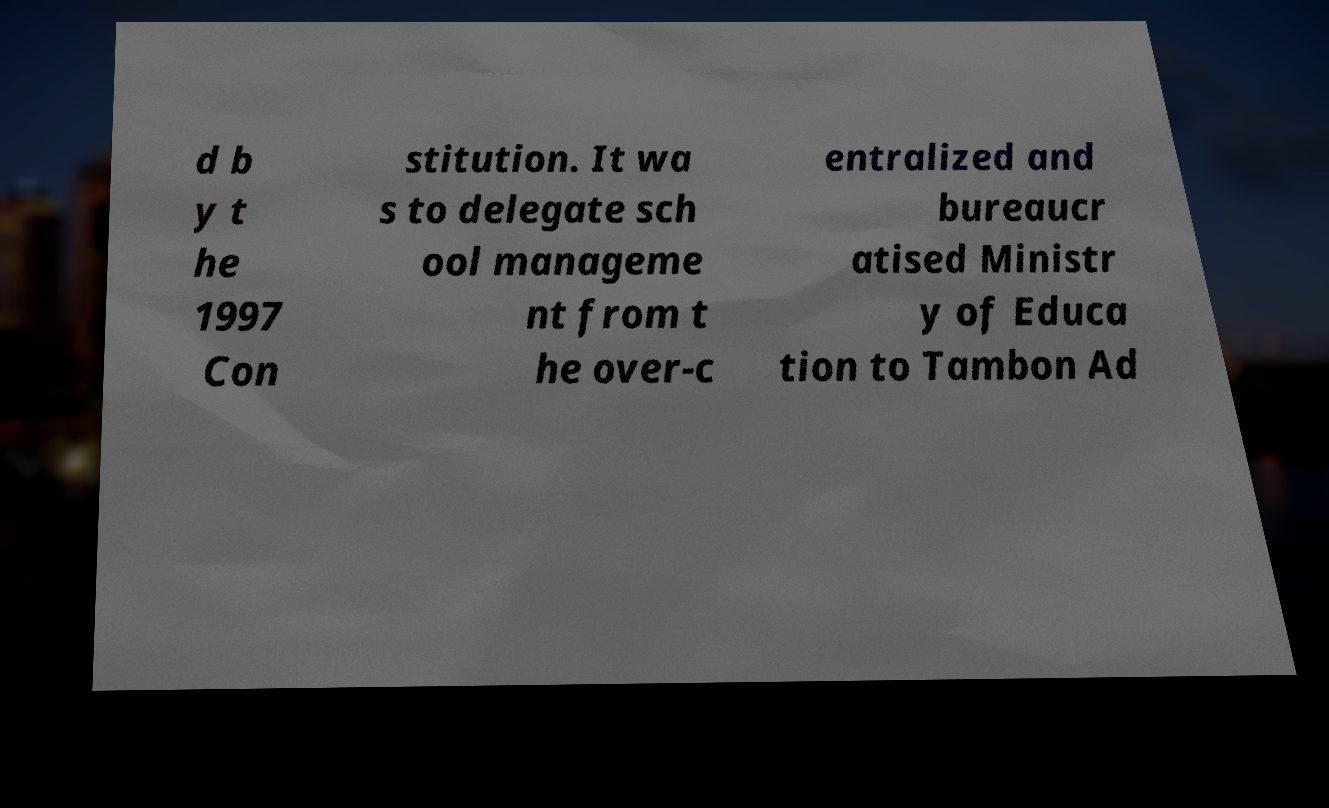I need the written content from this picture converted into text. Can you do that? d b y t he 1997 Con stitution. It wa s to delegate sch ool manageme nt from t he over-c entralized and bureaucr atised Ministr y of Educa tion to Tambon Ad 